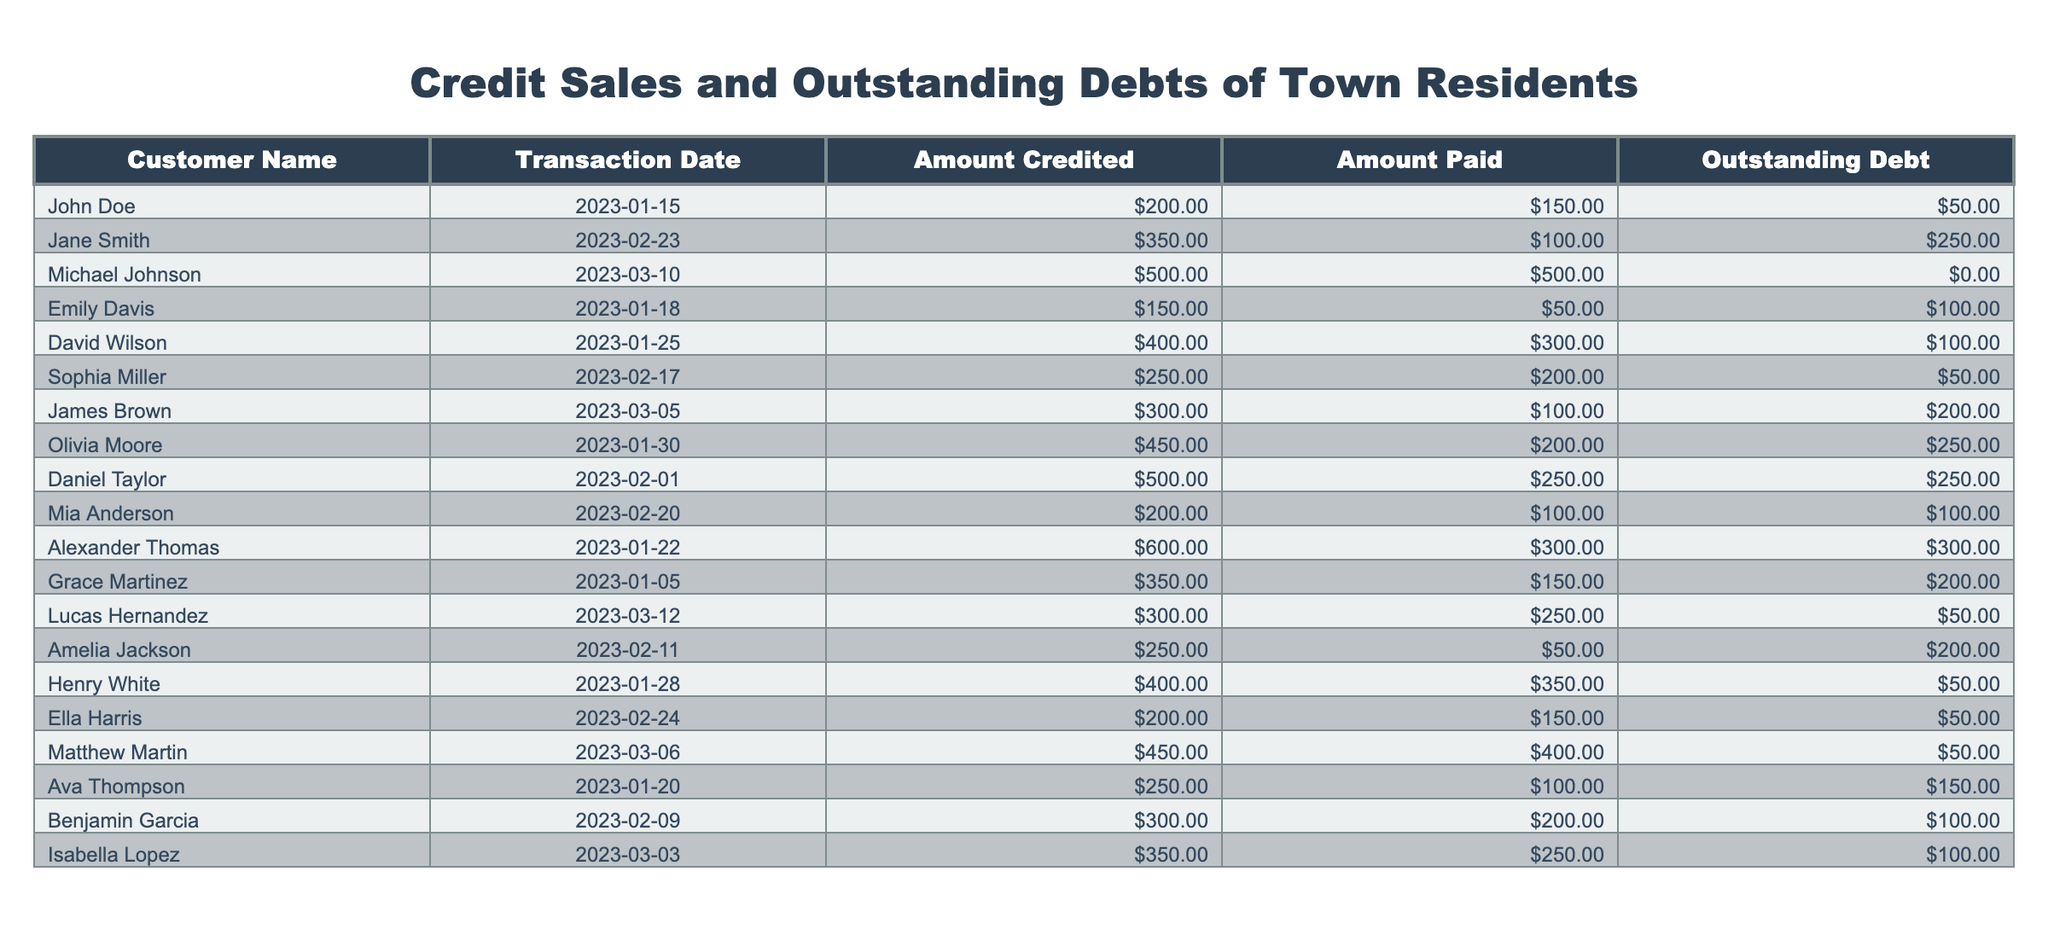What is the total amount of outstanding debt among all customers? To find the total outstanding debt, I will sum the "Outstanding Debt" column which contains the values [50, 250, 0, 100, 100, 50, 200, 250, 100, 300, 200, 50, 200, 50, 50, 150, 100]. Adding these values gives 50 + 250 + 0 + 100 + 100 + 50 + 200 + 250 + 100 + 300 + 200 + 50 + 200 + 50 + 50 + 150 + 100 = 2,400.
Answer: 2400 Who has the highest outstanding debt? To determine who has the highest outstanding debt, I will look for the maximum value in the "Outstanding Debt" column. The maximum amount is 300, which corresponds to Alexander Thomas.
Answer: Alexander Thomas How much did Jane Smith originally credit? I will find Jane Smith in the table and check the corresponding "Amount Credited" for her entry. Jane Smith's originally credited amount is 350.
Answer: 350 Is there any customer with an outstanding debt of zero? I need to check the "Outstanding Debt" column for any entry that equals zero. Michael Johnson is the customer with an outstanding debt of zero. Thus, the statement is true.
Answer: Yes What is the average amount paid by customers? To find the average amount paid, I will sum the "Amount Paid" values [150, 100, 500, 50, 300, 200, 100, 200, 250, 400, 100, 250, 150, 250, 400] which equals 2,900. There are 15 customers, so the average is 2,900 / 15 = 193.33.
Answer: 193.33 How many customers have outstanding debts greater than 100? I will count all customers whose "Outstanding Debt" is greater than 100. The customers with debts of 200, 250, and 300 exist in the table, leading to a total of 6 customers meeting this criteria.
Answer: 6 Which customer made the highest payment? I will examine the "Amount Paid" column for the maximum value. The maximum payment recorded is 500, made by Michael Johnson.
Answer: Michael Johnson What is the total amount credited and the total amount paid by Daniel Taylor? For Daniel Taylor, the "Amount Credited" is 500 and the "Amount Paid" is 250. Therefore, the total amount credited and paid is found by summing these two amounts: 500 + 250 = 750.
Answer: 750 